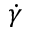Convert formula to latex. <formula><loc_0><loc_0><loc_500><loc_500>\dot { \gamma }</formula> 